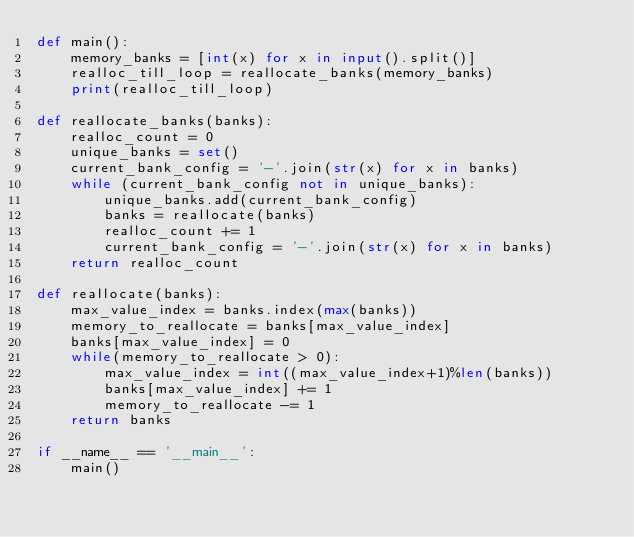<code> <loc_0><loc_0><loc_500><loc_500><_Python_>def main():
    memory_banks = [int(x) for x in input().split()]
    realloc_till_loop = reallocate_banks(memory_banks)
    print(realloc_till_loop)

def reallocate_banks(banks):
    realloc_count = 0
    unique_banks = set()
    current_bank_config = '-'.join(str(x) for x in banks)
    while (current_bank_config not in unique_banks):
        unique_banks.add(current_bank_config)
        banks = reallocate(banks)
        realloc_count += 1
        current_bank_config = '-'.join(str(x) for x in banks)
    return realloc_count

def reallocate(banks):
    max_value_index = banks.index(max(banks))
    memory_to_reallocate = banks[max_value_index]
    banks[max_value_index] = 0
    while(memory_to_reallocate > 0):
        max_value_index = int((max_value_index+1)%len(banks))
        banks[max_value_index] += 1
        memory_to_reallocate -= 1
    return banks

if __name__ == '__main__':
    main()</code> 